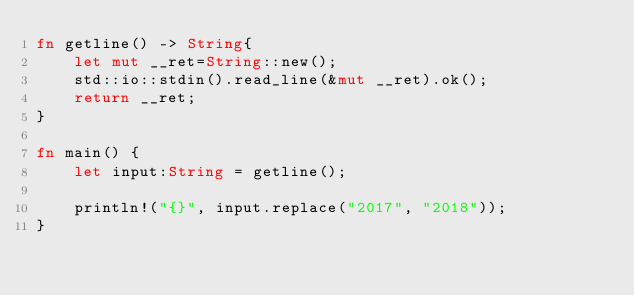<code> <loc_0><loc_0><loc_500><loc_500><_Rust_>fn getline() -> String{
	let mut __ret=String::new();
	std::io::stdin().read_line(&mut __ret).ok();
	return __ret;
}

fn main() {
    let input:String = getline();

    println!("{}", input.replace("2017", "2018"));
}</code> 